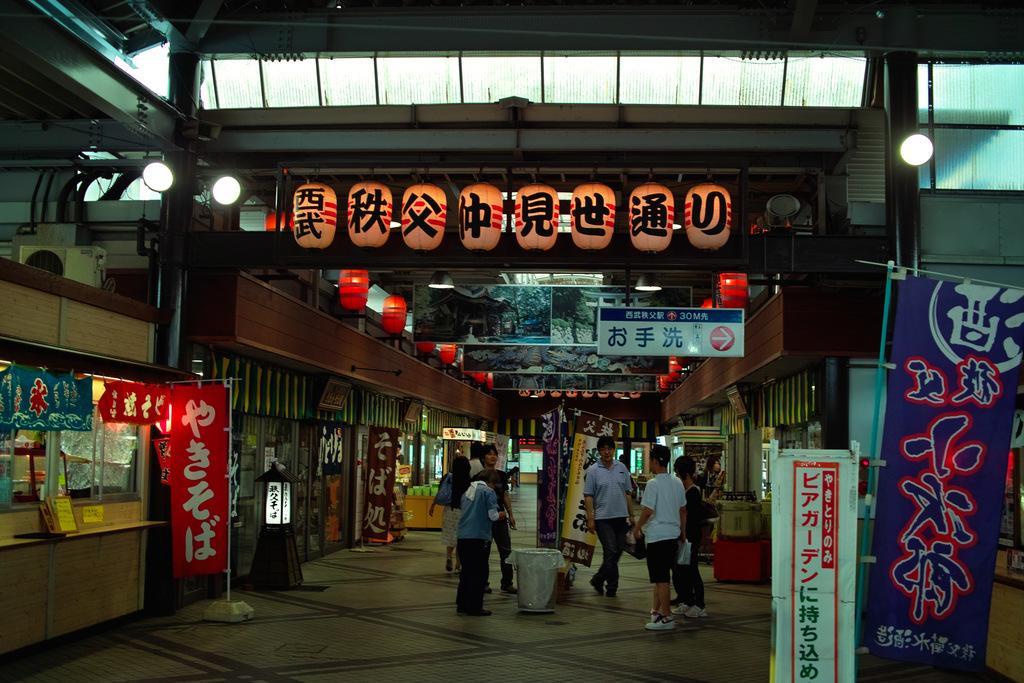Could you give a brief overview of what you see in this image? In this picture I can see group of people standing, there are shops, there are boards, lights, banners, there are paper lanterns and some other objects. 